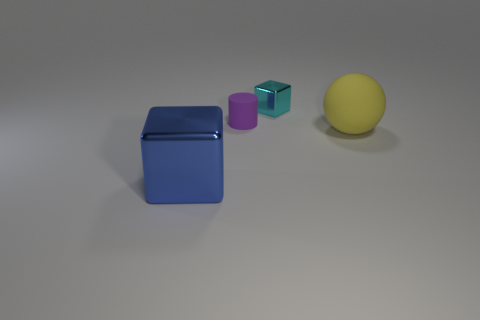What number of other objects are the same size as the matte ball?
Provide a succinct answer. 1. What number of objects are behind the large metallic cube and in front of the purple object?
Offer a terse response. 1. Do the metal cube on the left side of the purple cylinder and the rubber object right of the small purple matte object have the same size?
Keep it short and to the point. Yes. There is a shiny thing on the right side of the big blue object; what size is it?
Your answer should be very brief. Small. How many things are rubber objects left of the small shiny block or tiny purple things that are in front of the small cyan metal block?
Keep it short and to the point. 1. Is the number of blue cubes that are in front of the tiny metallic thing the same as the number of metal blocks behind the large blue shiny object?
Keep it short and to the point. Yes. Are there more small purple rubber cylinders that are on the right side of the blue object than blue rubber spheres?
Ensure brevity in your answer.  Yes. How many things are things on the right side of the blue block or big yellow rubber things?
Offer a very short reply. 3. What number of cyan cubes have the same material as the cylinder?
Provide a succinct answer. 0. Are there any cyan objects that have the same shape as the large blue metal thing?
Offer a terse response. Yes. 